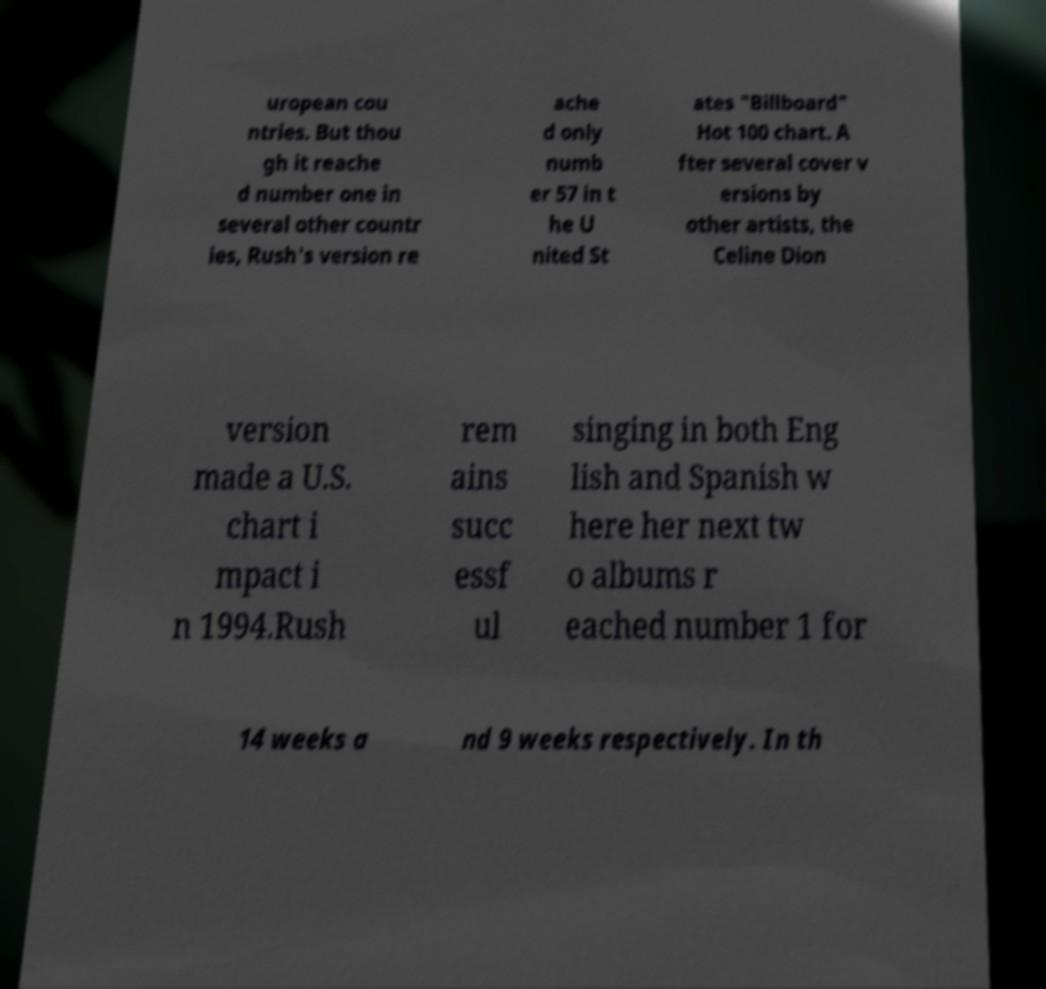Could you extract and type out the text from this image? uropean cou ntries. But thou gh it reache d number one in several other countr ies, Rush's version re ache d only numb er 57 in t he U nited St ates "Billboard" Hot 100 chart. A fter several cover v ersions by other artists, the Celine Dion version made a U.S. chart i mpact i n 1994.Rush rem ains succ essf ul singing in both Eng lish and Spanish w here her next tw o albums r eached number 1 for 14 weeks a nd 9 weeks respectively. In th 